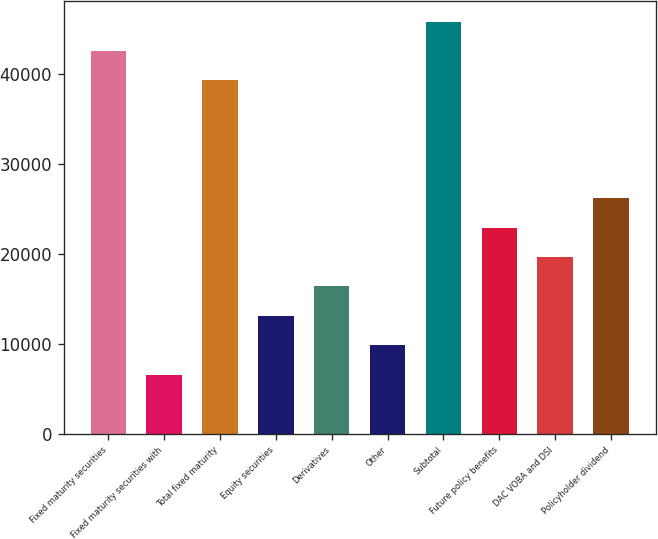Convert chart. <chart><loc_0><loc_0><loc_500><loc_500><bar_chart><fcel>Fixed maturity securities<fcel>Fixed maturity securities with<fcel>Total fixed maturity<fcel>Equity securities<fcel>Derivatives<fcel>Other<fcel>Subtotal<fcel>Future policy benefits<fcel>DAC VOBA and DSI<fcel>Policyholder dividend<nl><fcel>42595<fcel>6581<fcel>39321<fcel>13129<fcel>16403<fcel>9855<fcel>45869<fcel>22951<fcel>19677<fcel>26225<nl></chart> 